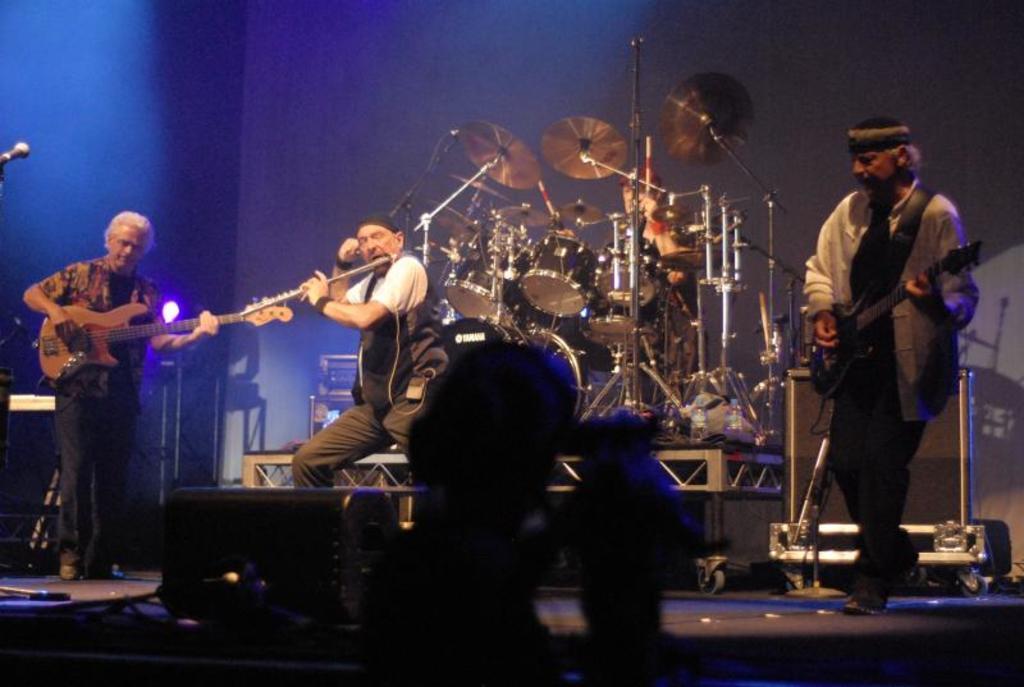Could you give a brief overview of what you see in this image? In this image, we can see few people are playing musical instruments on the stage. Background we can see rods, light, few objects, drum kit. Here we can see black color box and person. 